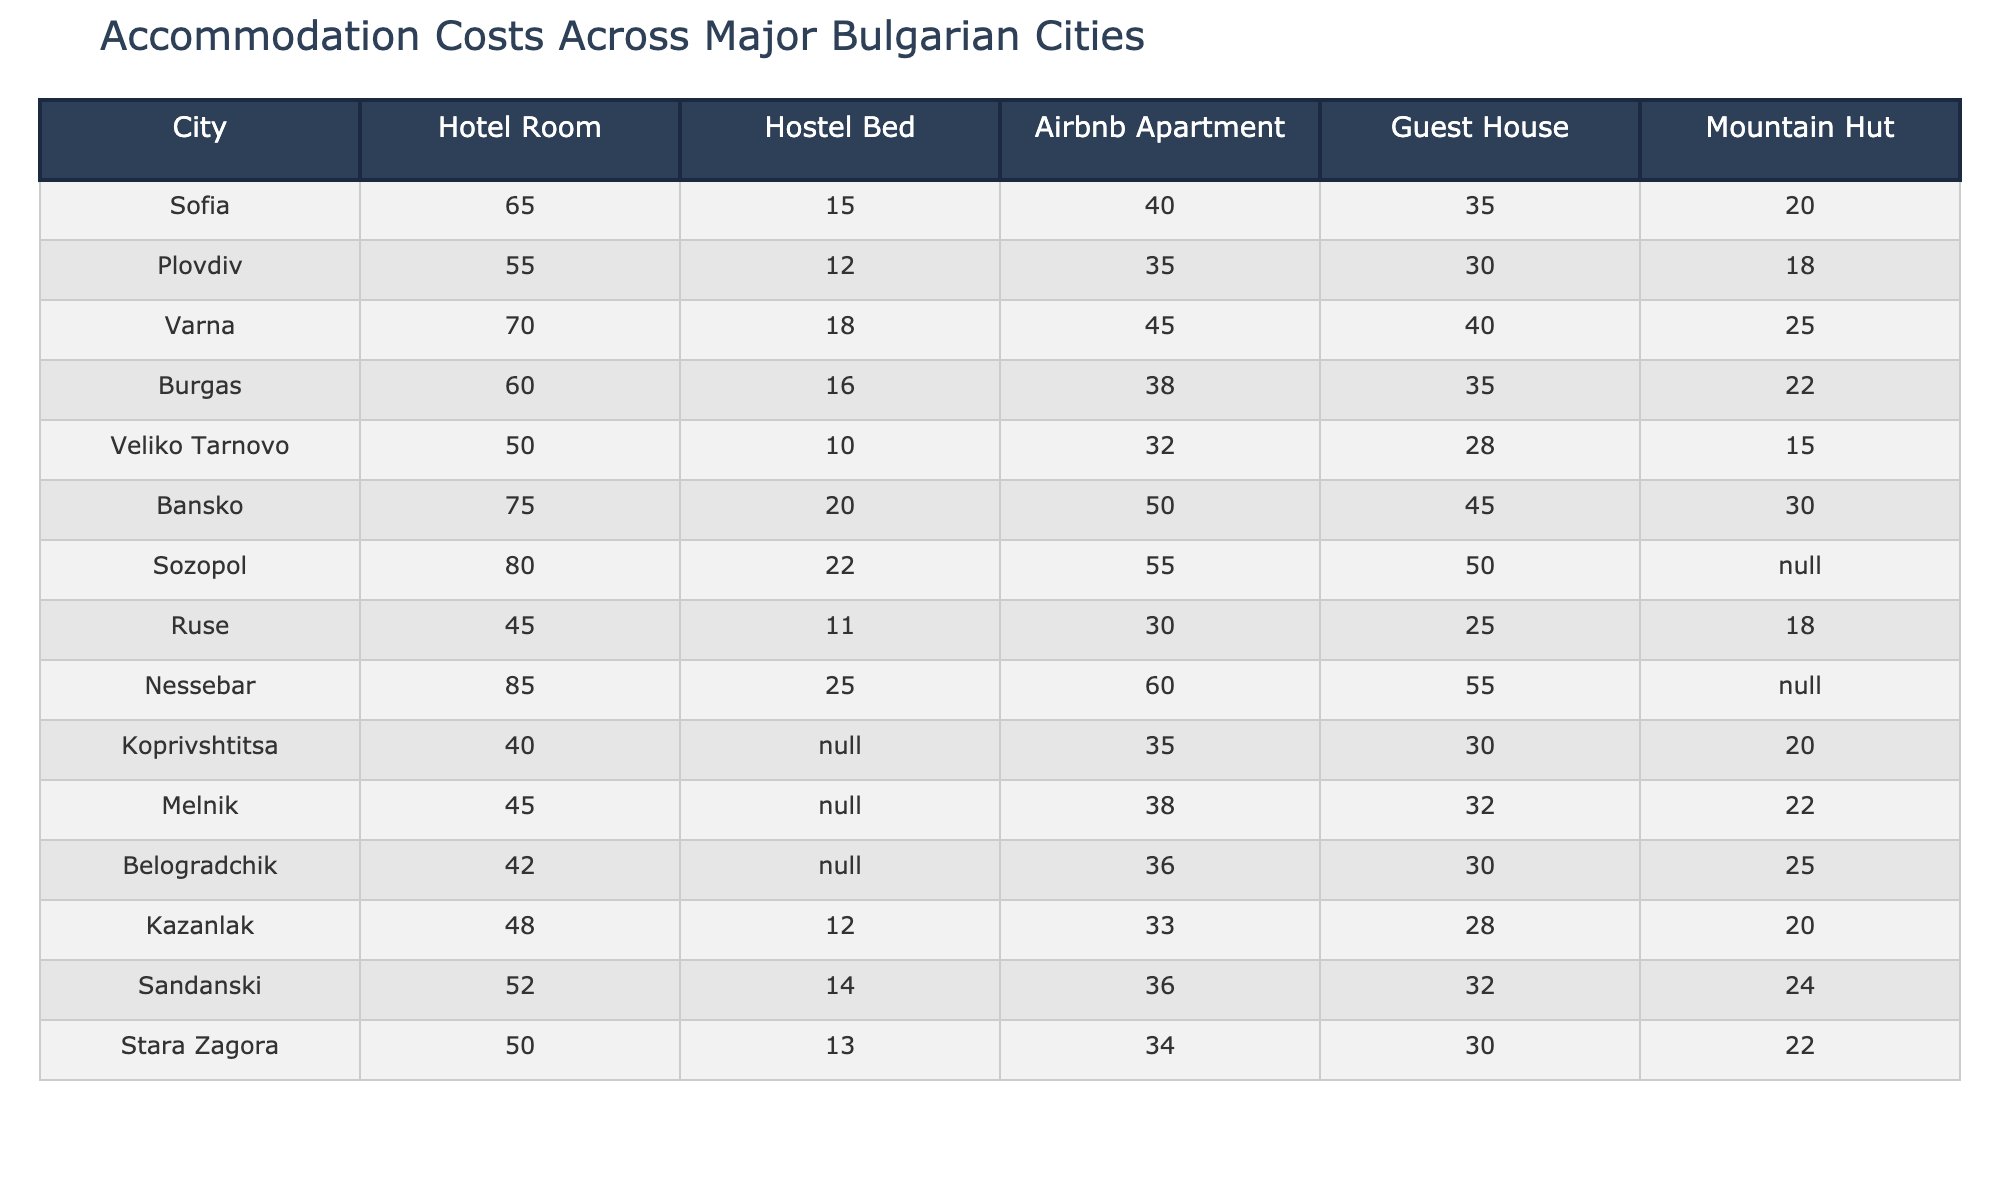What is the cost of a hotel room in Sofia? The table lists Sofia's hotel room cost as 65.
Answer: 65 Which city has the lowest cost for a hostel bed? By looking at the hostel bed costs, Veliko Tarnovo has the lowest price at 10.
Answer: 10 How much does an Airbnb apartment cost in Nessebar? The cost of an Airbnb apartment in Nessebar is listed as 60.
Answer: 60 Is the guest house in Varna more expensive than in Plovdiv? Varna's guest house cost is 40, while Plovdiv's is 30, making Varna's guest house more expensive.
Answer: Yes What is the average cost of a mountain hut across all cities listed? Adding the mountain hut costs where available: (20 + 18 + 25 + 22 + 15 + 30 + 20 + 24 + 22) =  184, and there are 9 cities, so the average is 184/9 ≈ 20.44.
Answer: Approximately 20.44 Which city has the highest cost for a guest house? By comparing guest house prices, Nessebar has the highest cost at 55.
Answer: 55 Which type of accommodation is the most expensive in Bansko? The table shows that the hotel room in Bansko is the most expensive at 75.
Answer: 75 How does the cost of an Airbnb apartment in Varna compare to that in Plovdiv? Varna's Airbnb cost is 45, higher than Plovdiv's 35, indicating that Varna's is more expensive.
Answer: Varna's is more expensive If I wanted to stay in a mountain hut in Burgas and a guest house in Veliko Tarnovo, how much would that cost in total? The mountain hut in Burgas costs 22, and the guest house in Veliko Tarnovo costs 28, so the total cost is 22 + 28 = 50.
Answer: 50 Is the cost of a hotel room in Ruse higher than in Kazanlak? The hotel room in Ruse costs 45, while Kazanlak's is 48, so Ruse's is not higher.
Answer: No 